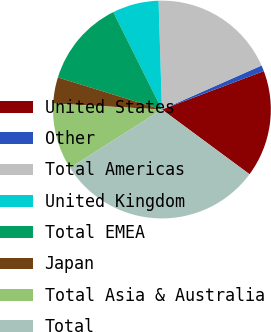Convert chart. <chart><loc_0><loc_0><loc_500><loc_500><pie_chart><fcel>United States<fcel>Other<fcel>Total Americas<fcel>United Kingdom<fcel>Total EMEA<fcel>Japan<fcel>Total Asia & Australia<fcel>Total<nl><fcel>15.87%<fcel>0.88%<fcel>18.87%<fcel>6.88%<fcel>12.87%<fcel>3.88%<fcel>9.88%<fcel>30.87%<nl></chart> 